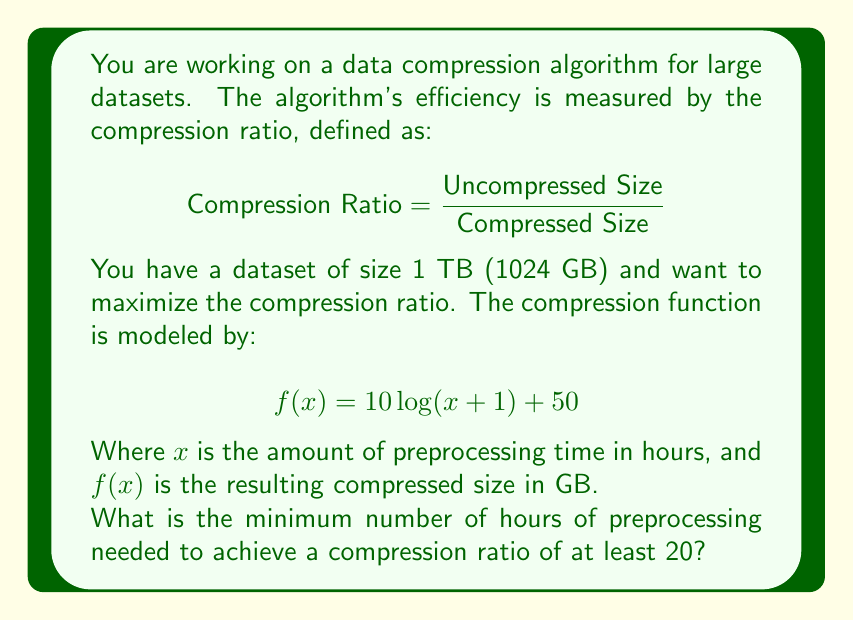What is the answer to this math problem? To solve this problem, we'll follow these steps:

1. Set up the inequality for the compression ratio:
   $$ \frac{\text{Uncompressed Size}}{\text{Compressed Size}} \geq 20 $$

2. Substitute the known values:
   $$ \frac{1024}{f(x)} \geq 20 $$

3. Substitute the compression function:
   $$ \frac{1024}{10 \log(x + 1) + 50} \geq 20 $$

4. Solve the inequality:
   $$ 10 \log(x + 1) + 50 \leq \frac{1024}{20} = 51.2 $$
   $$ 10 \log(x + 1) \leq 1.2 $$
   $$ \log(x + 1) \leq 0.12 $$
   $$ x + 1 \leq 10^{0.12} $$
   $$ x \leq 10^{0.12} - 1 $$
   $$ x \leq 0.3187 $$

5. Since we need the minimum number of hours and x represents time, we round up to the nearest hour.
Answer: The minimum number of hours of preprocessing needed to achieve a compression ratio of at least 20 is 1 hour. 